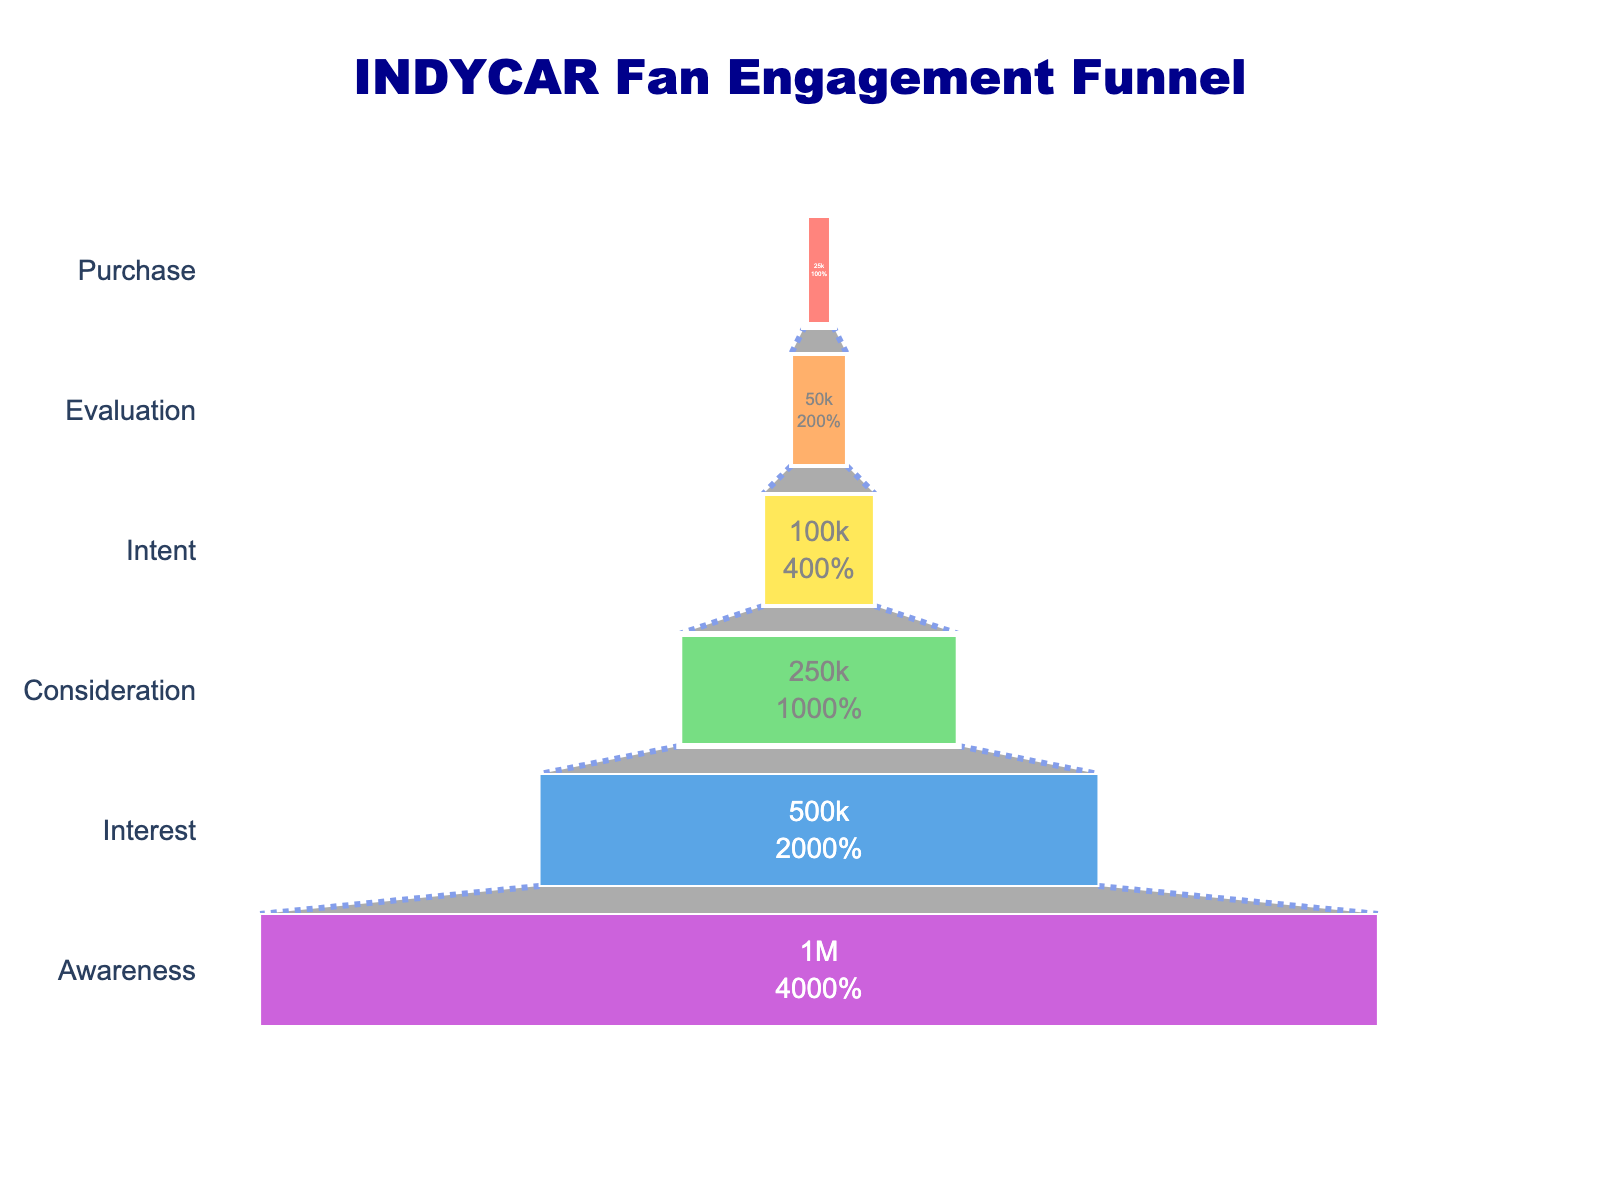What's the title of this funnel chart? The answer is explicitly displayed at the top of the chart. The title, written in dark blue, reads "INDYCAR Fan Engagement Funnel".
Answer: INDYCAR Fan Engagement Funnel What are the stages in the fan engagement funnel? The stages can be identified from the labels on the y-axis. They include Awareness, Interest, Consideration, Intent, Evaluation, and Purchase.
Answer: Awareness, Interest, Consideration, Intent, Evaluation, Purchase How many fans are at the Interest stage? According to the figure, the number of fans at the Interest stage is labeled inside the corresponding bar. The value displayed is 500,000.
Answer: 500,000 What percentage of initial fans reach the Purchase stage? The chart uses text info to show the percentage of fans that reach each stage, based on the initial number of fans. The Purchase stage shows 2.5%, meaning 2.5% of the initial million fans reach this stage.
Answer: 2.5% How many more fans are in the Awareness stage compared to the Intent stage? There are 1,000,000 fans in the Awareness stage and 100,000 fans in the Intent stage. The difference is calculated as 1,000,000 - 100,000.
Answer: 900,000 Which stage has exactly half the number of fans than the previous stage? By comparing the number of fans between stages, we see that multiple reductions reflect this condition. However, a key stage is the Consideration stage with 250,000 fans, half of the Interest stage with 500,000 fans.
Answer: Consideration Which two stages have the greatest drop in fan numbers between them? To identify the biggest drop, we look for the largest difference between consecutive stages. From Interest (500,000) to Consideration (250,000), the drop is 250,000 which is the largest.
Answer: Interest to Consideration Compare the number of fans at the Evaluation stage to those at the Consideration stage. The chart shows 50,000 fans at the Evaluation stage and 250,000 fans at the Consideration stage. Since 50,000 is less than 250,000, the Evaluation stage has fewer fans.
Answer: Fewer What's the aggregate number of fans in the Intent, Evaluation, and Purchase stages? Summing up the fans in these stages: Intent (100,000) + Evaluation (50,000) + Purchase (25,000) gives 175,000 fans.
Answer: 175,000 What does each color in the funnel represent? Each segment of the funnel is colored differently to distinguish the stages, in descending numerical order: red for Awareness, orange for Interest, yellow for Consideration, green for Intent, blue for Evaluation, and purple for Purchase.
Answer: Different stages 